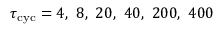Convert formula to latex. <formula><loc_0><loc_0><loc_500><loc_500>\tau _ { c y c } = 4 , \ 8 , \ 2 0 , \ 4 0 , \ 2 0 0 , \ 4 0 0</formula> 